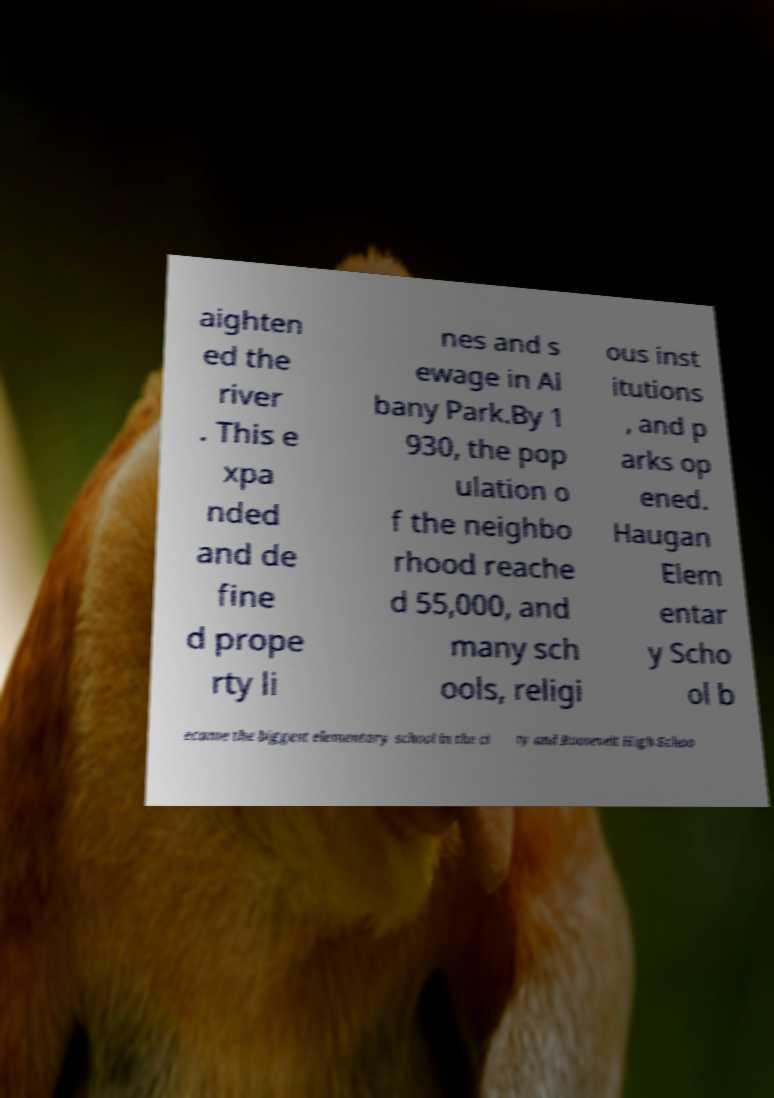I need the written content from this picture converted into text. Can you do that? aighten ed the river . This e xpa nded and de fine d prope rty li nes and s ewage in Al bany Park.By 1 930, the pop ulation o f the neighbo rhood reache d 55,000, and many sch ools, religi ous inst itutions , and p arks op ened. Haugan Elem entar y Scho ol b ecame the biggest elementary school in the ci ty and Roosevelt High Schoo 